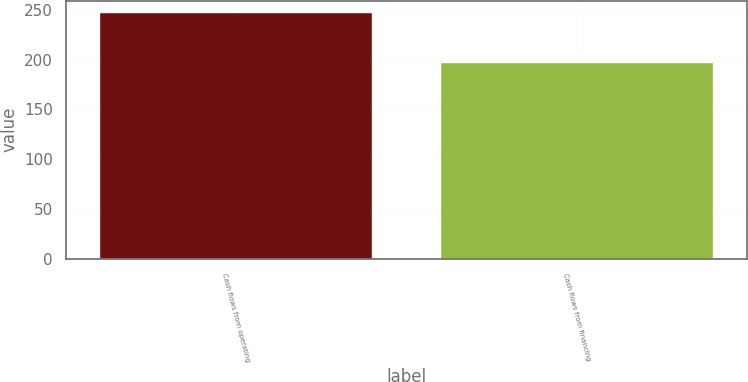Convert chart to OTSL. <chart><loc_0><loc_0><loc_500><loc_500><bar_chart><fcel>Cash flows from operating<fcel>Cash flows from financing<nl><fcel>246.7<fcel>196.8<nl></chart> 